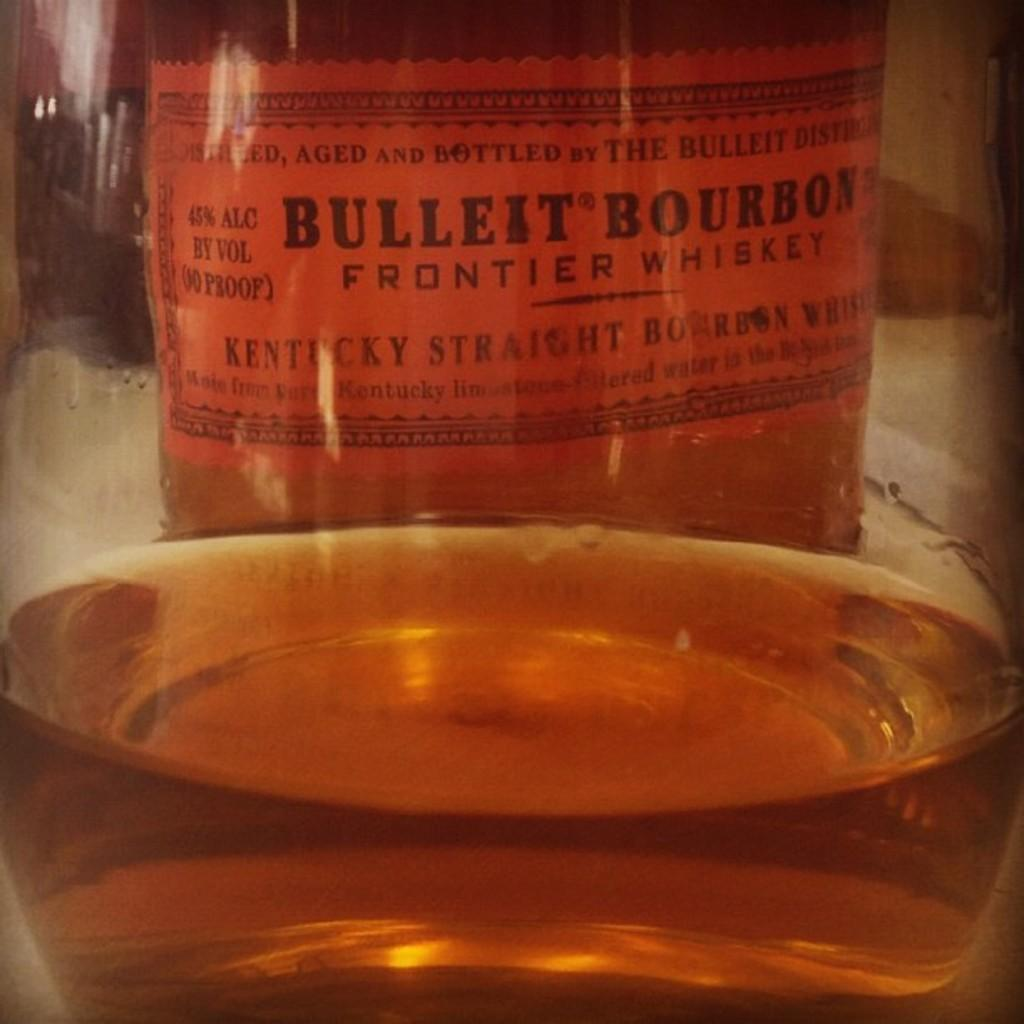<image>
Summarize the visual content of the image. Bulleit Bourbon Frontier Whiskey is made with Kentucky bourbon. 